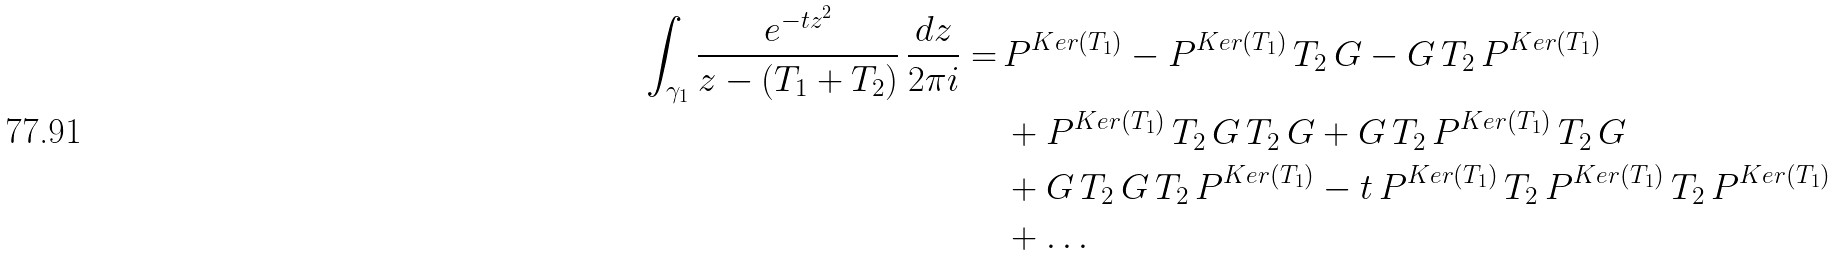Convert formula to latex. <formula><loc_0><loc_0><loc_500><loc_500>\int _ { \gamma _ { 1 } } \frac { e ^ { - t z ^ { 2 } } } { z - ( T _ { 1 } + T _ { 2 } ) } \, \frac { d z } { 2 \pi i } = \, & P ^ { K e r ( T _ { 1 } ) } - P ^ { K e r ( T _ { 1 } ) } \, T _ { 2 } \, G - G \, T _ { 2 } \, P ^ { K e r ( T _ { 1 } ) } \\ & + P ^ { K e r ( T _ { 1 } ) } \, T _ { 2 } \, G \, T _ { 2 } \, G + G \, T _ { 2 } \, P ^ { K e r ( T _ { 1 } ) } \, T _ { 2 } \, G \\ & + G \, T _ { 2 } \, G \, T _ { 2 } \, P ^ { K e r ( T _ { 1 } ) } - t \, P ^ { K e r ( T _ { 1 } ) } \, T _ { 2 } \, P ^ { K e r ( T _ { 1 } ) } \, T _ { 2 } \, P ^ { K e r ( T _ { 1 } ) } \\ & + \dots</formula> 